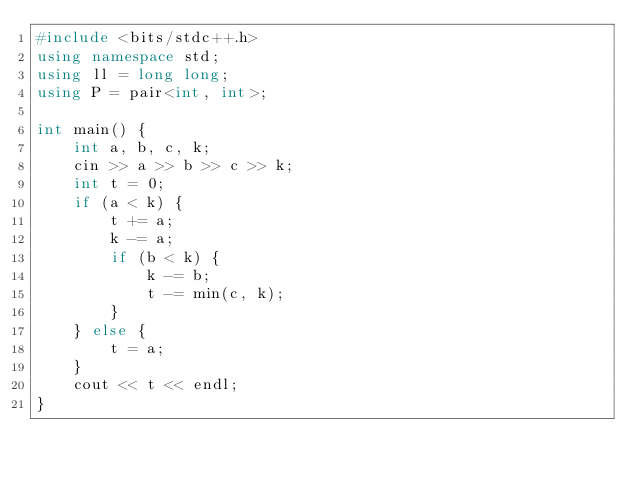Convert code to text. <code><loc_0><loc_0><loc_500><loc_500><_C++_>#include <bits/stdc++.h>
using namespace std;
using ll = long long;
using P = pair<int, int>;

int main() {
    int a, b, c, k;
    cin >> a >> b >> c >> k;
    int t = 0;
    if (a < k) {
        t += a;
        k -= a;
        if (b < k) {
            k -= b;
            t -= min(c, k);
        }
    } else {
        t = a;
    }
    cout << t << endl;
}</code> 